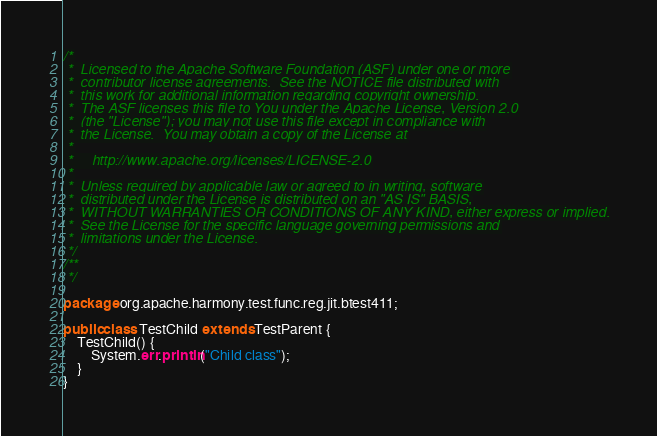Convert code to text. <code><loc_0><loc_0><loc_500><loc_500><_Java_>/*
 *  Licensed to the Apache Software Foundation (ASF) under one or more
 *  contributor license agreements.  See the NOTICE file distributed with
 *  this work for additional information regarding copyright ownership.
 *  The ASF licenses this file to You under the Apache License, Version 2.0
 *  (the "License"); you may not use this file except in compliance with
 *  the License.  You may obtain a copy of the License at
 *
 *     http://www.apache.org/licenses/LICENSE-2.0
 *
 *  Unless required by applicable law or agreed to in writing, software
 *  distributed under the License is distributed on an "AS IS" BASIS,
 *  WITHOUT WARRANTIES OR CONDITIONS OF ANY KIND, either express or implied.
 *  See the License for the specific language governing permissions and
 *  limitations under the License.
 */
/**
 */

package org.apache.harmony.test.func.reg.jit.btest411;

public class TestChild extends TestParent {
    TestChild() {
        System.err.println("Child class");
    }
}
</code> 